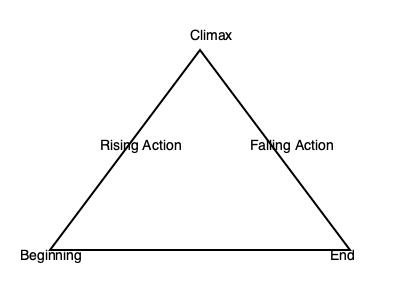In the context of thriller writing, which element of plot structure is most crucial for maintaining suspense and should be placed at the apex of the plot pyramid? To answer this question, let's consider the key elements of thriller writing and plot structure:

1. Thriller writing relies heavily on suspense and tension to engage readers.
2. The plot pyramid illustrates the basic structure of a story, with the climax at the apex.
3. The climax is the point of highest tension in a story, where the main conflict reaches its peak.
4. In thrillers, the climax often involves the protagonist facing their greatest challenge or danger.
5. The rising action leads up to the climax, building tension and suspense.
6. The falling action follows the climax, resolving the main conflict.
7. For a thriller writer, the climax is crucial as it's where the suspense culminates and the story's central mystery or conflict is typically resolved.

Therefore, the element that should be placed at the apex of the plot pyramid, which is most crucial for maintaining suspense in thriller writing, is the climax.
Answer: Climax 